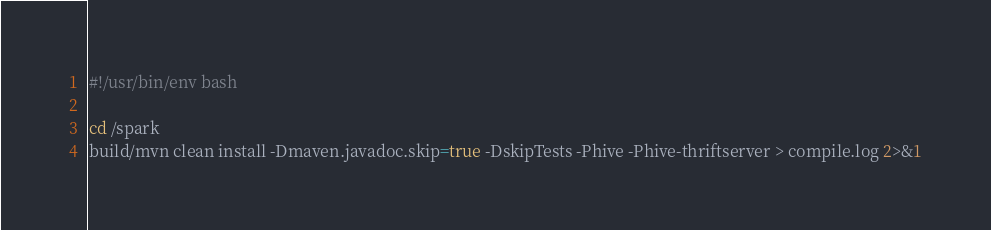<code> <loc_0><loc_0><loc_500><loc_500><_Bash_>#!/usr/bin/env bash

cd /spark
build/mvn clean install -Dmaven.javadoc.skip=true -DskipTests -Phive -Phive-thriftserver > compile.log 2>&1
</code> 